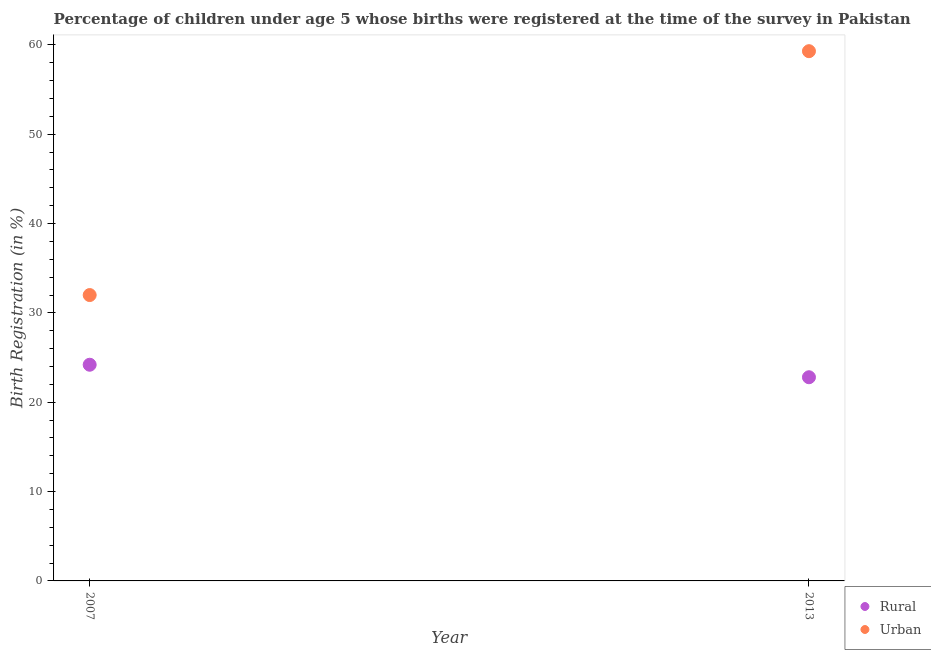What is the rural birth registration in 2007?
Give a very brief answer. 24.2. Across all years, what is the maximum rural birth registration?
Your answer should be very brief. 24.2. Across all years, what is the minimum rural birth registration?
Provide a succinct answer. 22.8. In which year was the rural birth registration maximum?
Keep it short and to the point. 2007. What is the difference between the rural birth registration in 2007 and that in 2013?
Your answer should be compact. 1.4. What is the difference between the rural birth registration in 2007 and the urban birth registration in 2013?
Give a very brief answer. -35.1. In the year 2007, what is the difference between the urban birth registration and rural birth registration?
Keep it short and to the point. 7.8. What is the ratio of the rural birth registration in 2007 to that in 2013?
Ensure brevity in your answer.  1.06. In how many years, is the rural birth registration greater than the average rural birth registration taken over all years?
Offer a terse response. 1. Does the rural birth registration monotonically increase over the years?
Provide a succinct answer. No. Is the rural birth registration strictly less than the urban birth registration over the years?
Provide a succinct answer. Yes. How many dotlines are there?
Provide a succinct answer. 2. How many years are there in the graph?
Offer a terse response. 2. What is the difference between two consecutive major ticks on the Y-axis?
Make the answer very short. 10. Does the graph contain any zero values?
Your answer should be compact. No. Does the graph contain grids?
Make the answer very short. No. What is the title of the graph?
Ensure brevity in your answer.  Percentage of children under age 5 whose births were registered at the time of the survey in Pakistan. Does "Grants" appear as one of the legend labels in the graph?
Provide a short and direct response. No. What is the label or title of the X-axis?
Give a very brief answer. Year. What is the label or title of the Y-axis?
Ensure brevity in your answer.  Birth Registration (in %). What is the Birth Registration (in %) of Rural in 2007?
Provide a short and direct response. 24.2. What is the Birth Registration (in %) in Urban in 2007?
Give a very brief answer. 32. What is the Birth Registration (in %) of Rural in 2013?
Offer a very short reply. 22.8. What is the Birth Registration (in %) in Urban in 2013?
Your answer should be very brief. 59.3. Across all years, what is the maximum Birth Registration (in %) of Rural?
Give a very brief answer. 24.2. Across all years, what is the maximum Birth Registration (in %) of Urban?
Make the answer very short. 59.3. Across all years, what is the minimum Birth Registration (in %) in Rural?
Keep it short and to the point. 22.8. Across all years, what is the minimum Birth Registration (in %) in Urban?
Make the answer very short. 32. What is the total Birth Registration (in %) of Urban in the graph?
Give a very brief answer. 91.3. What is the difference between the Birth Registration (in %) of Rural in 2007 and that in 2013?
Offer a very short reply. 1.4. What is the difference between the Birth Registration (in %) in Urban in 2007 and that in 2013?
Your answer should be very brief. -27.3. What is the difference between the Birth Registration (in %) of Rural in 2007 and the Birth Registration (in %) of Urban in 2013?
Make the answer very short. -35.1. What is the average Birth Registration (in %) in Urban per year?
Your answer should be compact. 45.65. In the year 2013, what is the difference between the Birth Registration (in %) in Rural and Birth Registration (in %) in Urban?
Your response must be concise. -36.5. What is the ratio of the Birth Registration (in %) of Rural in 2007 to that in 2013?
Offer a very short reply. 1.06. What is the ratio of the Birth Registration (in %) in Urban in 2007 to that in 2013?
Ensure brevity in your answer.  0.54. What is the difference between the highest and the second highest Birth Registration (in %) of Rural?
Your response must be concise. 1.4. What is the difference between the highest and the second highest Birth Registration (in %) of Urban?
Provide a short and direct response. 27.3. What is the difference between the highest and the lowest Birth Registration (in %) in Rural?
Your response must be concise. 1.4. What is the difference between the highest and the lowest Birth Registration (in %) of Urban?
Your answer should be very brief. 27.3. 